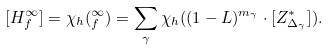Convert formula to latex. <formula><loc_0><loc_0><loc_500><loc_500>[ H _ { f } ^ { \infty } ] = \chi _ { h } ( _ { f } ^ { \infty } ) = \sum _ { \gamma } \chi _ { h } ( ( 1 - \L L ) ^ { m _ { \gamma } } \cdot [ Z _ { \Delta _ { \gamma } } ^ { * } ] ) .</formula> 